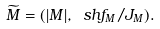Convert formula to latex. <formula><loc_0><loc_0><loc_500><loc_500>\widetilde { M } = ( | M | , \ s h f _ { M } / J _ { M } ) .</formula> 